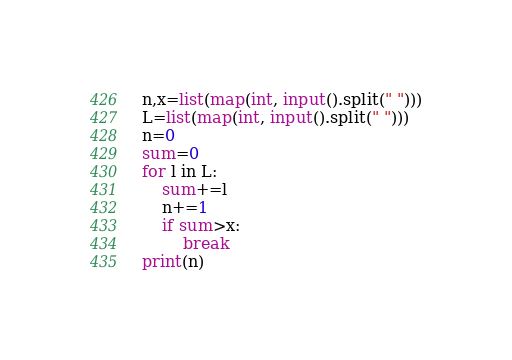Convert code to text. <code><loc_0><loc_0><loc_500><loc_500><_Python_>n,x=list(map(int, input().split(" ")))
L=list(map(int, input().split(" ")))
n=0
sum=0
for l in L:
    sum+=l
    n+=1
    if sum>x:
        break
print(n)</code> 